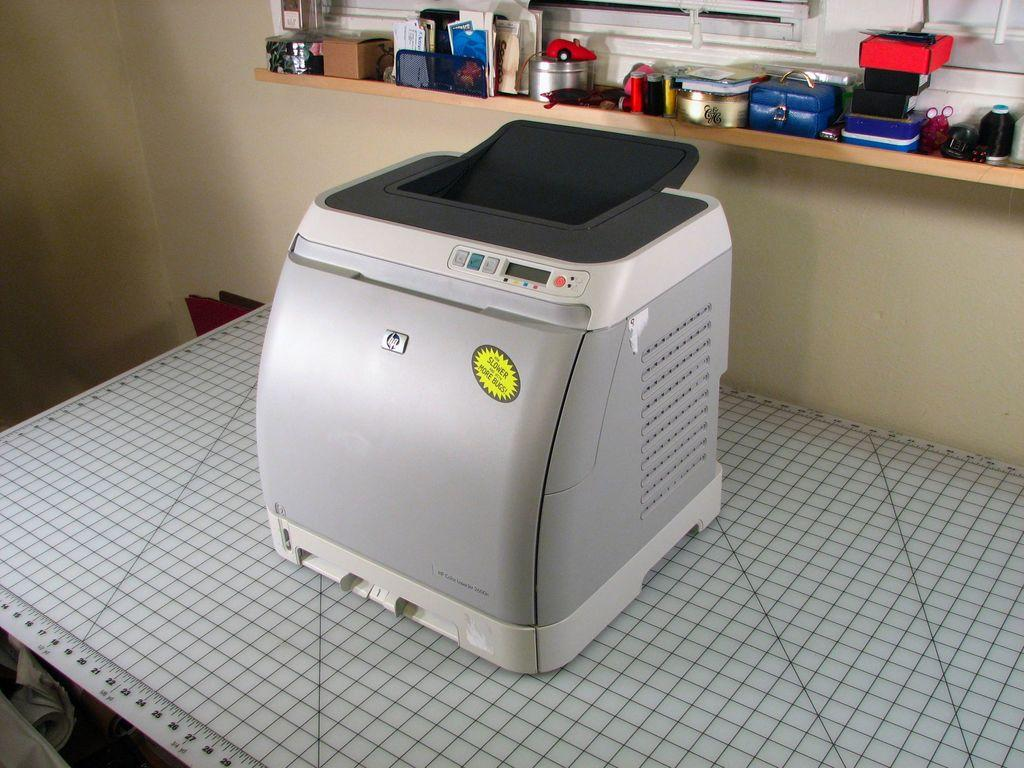What is the main object in the center of the image? There is a device in the center of the image. Where is the device located? The device is placed on a table. What can be seen in the foreground of the image? There are numbers visible in the foreground. What is visible in the background of the image? There are objects placed on a rack and windows visible in the background. What type of silver is the frog holding in the image? There is no frog or silver present in the image. 